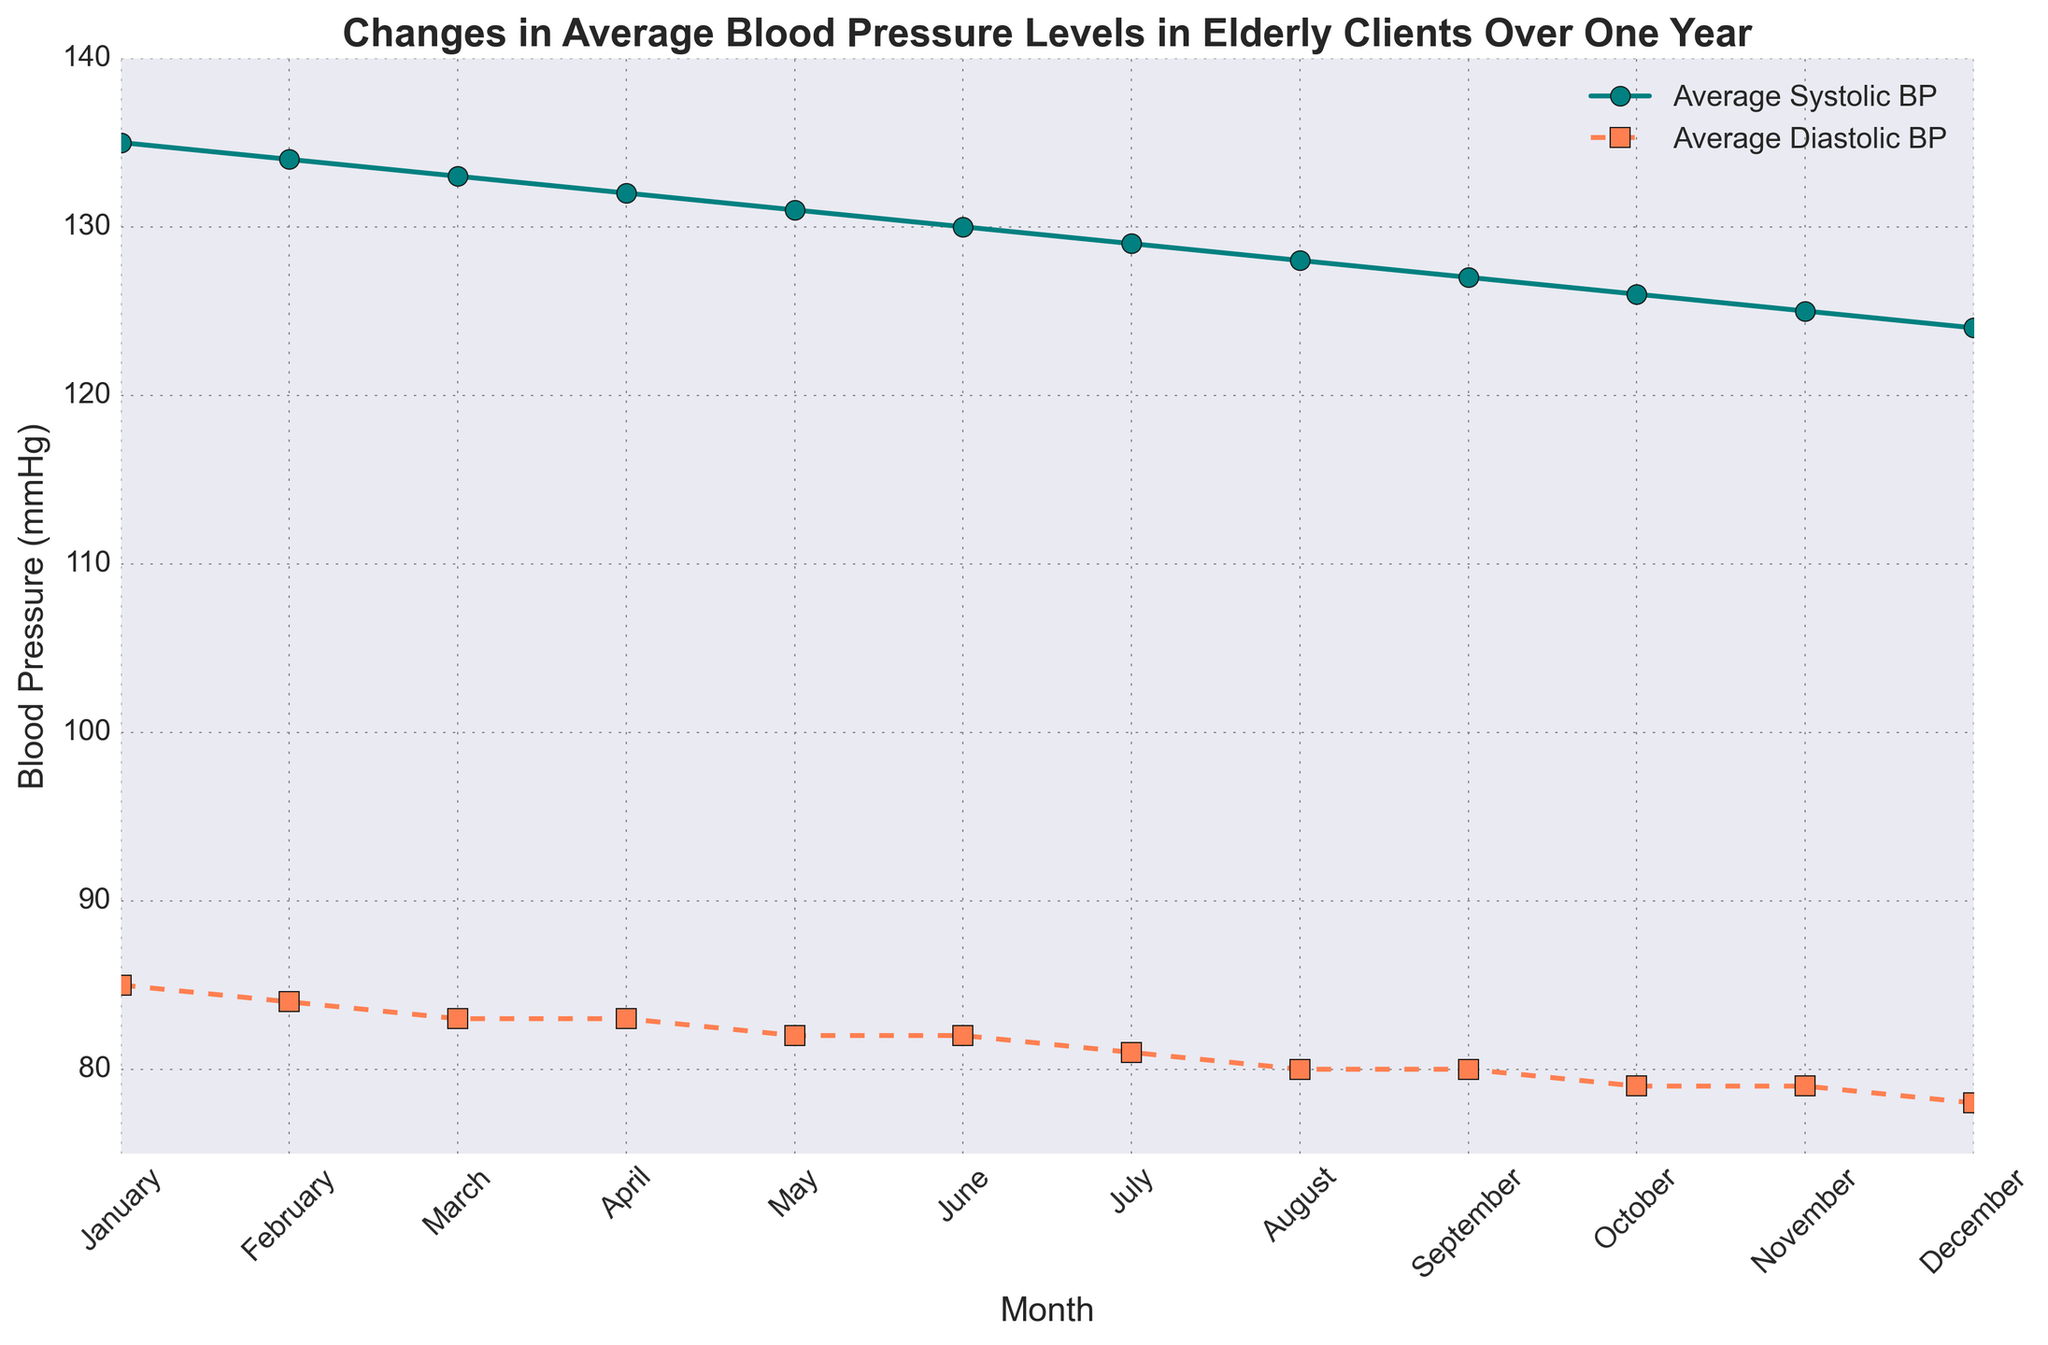What is the average systolic blood pressure in July? According to the figure, the average systolic blood pressure for July is found directly on the line chart where it shows the value for July.
Answer: 129 What is the overall trend of the average systolic blood pressure throughout the year? Observing the line representing systolic blood pressure from January to December, there is a clear downward slope, indicating a consistent decrease.
Answer: Continuous decrease What is the difference between the average systolic and diastolic blood pressure in March? Looking at the plot points for March, we see the systolic BP is 133 and the diastolic BP is 83. By subtracting the diastolic from the systolic (133 - 83), we get the difference.
Answer: 50 Which month shows the highest average diastolic blood pressure and what is its value? By comparing the diastolic BP line across all months, the highest point is at January with a value of 85.
Answer: January, 85 In which month did the systolic blood pressure drop below 130 for the first time? Following the systolic BP line, the first value under 130 occurs in July.
Answer: July How much did the average diastolic blood pressure decrease from January to December? Checking the plot values, diastolic BP in January is 85 and in December it is 78. The decrease is calculated as 85 - 78.
Answer: 7 Is the difference between average systolic and diastolic blood pressures constant throughout the year? Analyzing the distances between the two lines points month by month, they start at 50 in January and end at 46 in December, so the difference is not constant.
Answer: No What is the average diastolic blood pressure for the last six months of the year (July to December)? The values for July to December are 81, 80, 80, 79, 79, and 78. Adding them gives 477. Dividing by 6 (477/6) results in an average.
Answer: 79.5 How does the average systolic blood pressure in September compare to that in October? The plot shows that systolic BP in September is 127 and in October it is 126. Therefore, October's value is slightly lower.
Answer: Lower in October Which color represents the average diastolic blood pressure on the chart, and what is its visual style? The chart shows that the diastolic BP is represented by a coral-colored line with square markers and a dashed line style.
Answer: Coral, dashed with square markers 